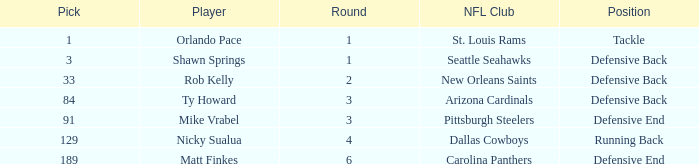What player has defensive back as the position, with a round less than 2? Shawn Springs. 